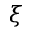<formula> <loc_0><loc_0><loc_500><loc_500>\xi</formula> 